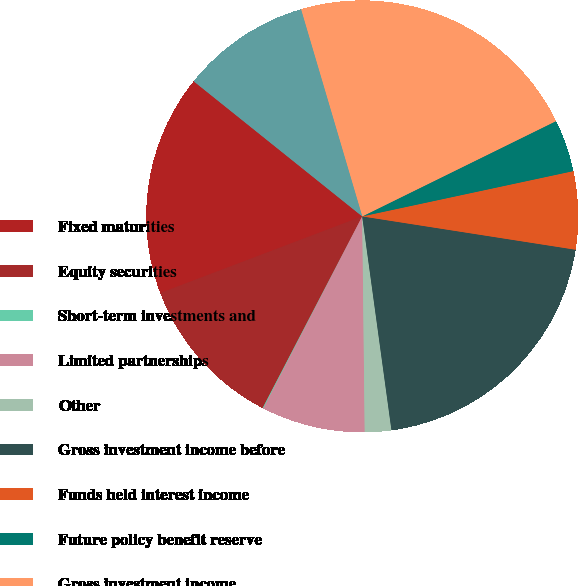<chart> <loc_0><loc_0><loc_500><loc_500><pie_chart><fcel>Fixed maturities<fcel>Equity securities<fcel>Short-term investments and<fcel>Limited partnerships<fcel>Other<fcel>Gross investment income before<fcel>Funds held interest income<fcel>Future policy benefit reserve<fcel>Gross investment income<fcel>Investment expenses<nl><fcel>16.53%<fcel>11.6%<fcel>0.06%<fcel>7.75%<fcel>1.98%<fcel>20.37%<fcel>5.83%<fcel>3.91%<fcel>22.3%<fcel>9.67%<nl></chart> 